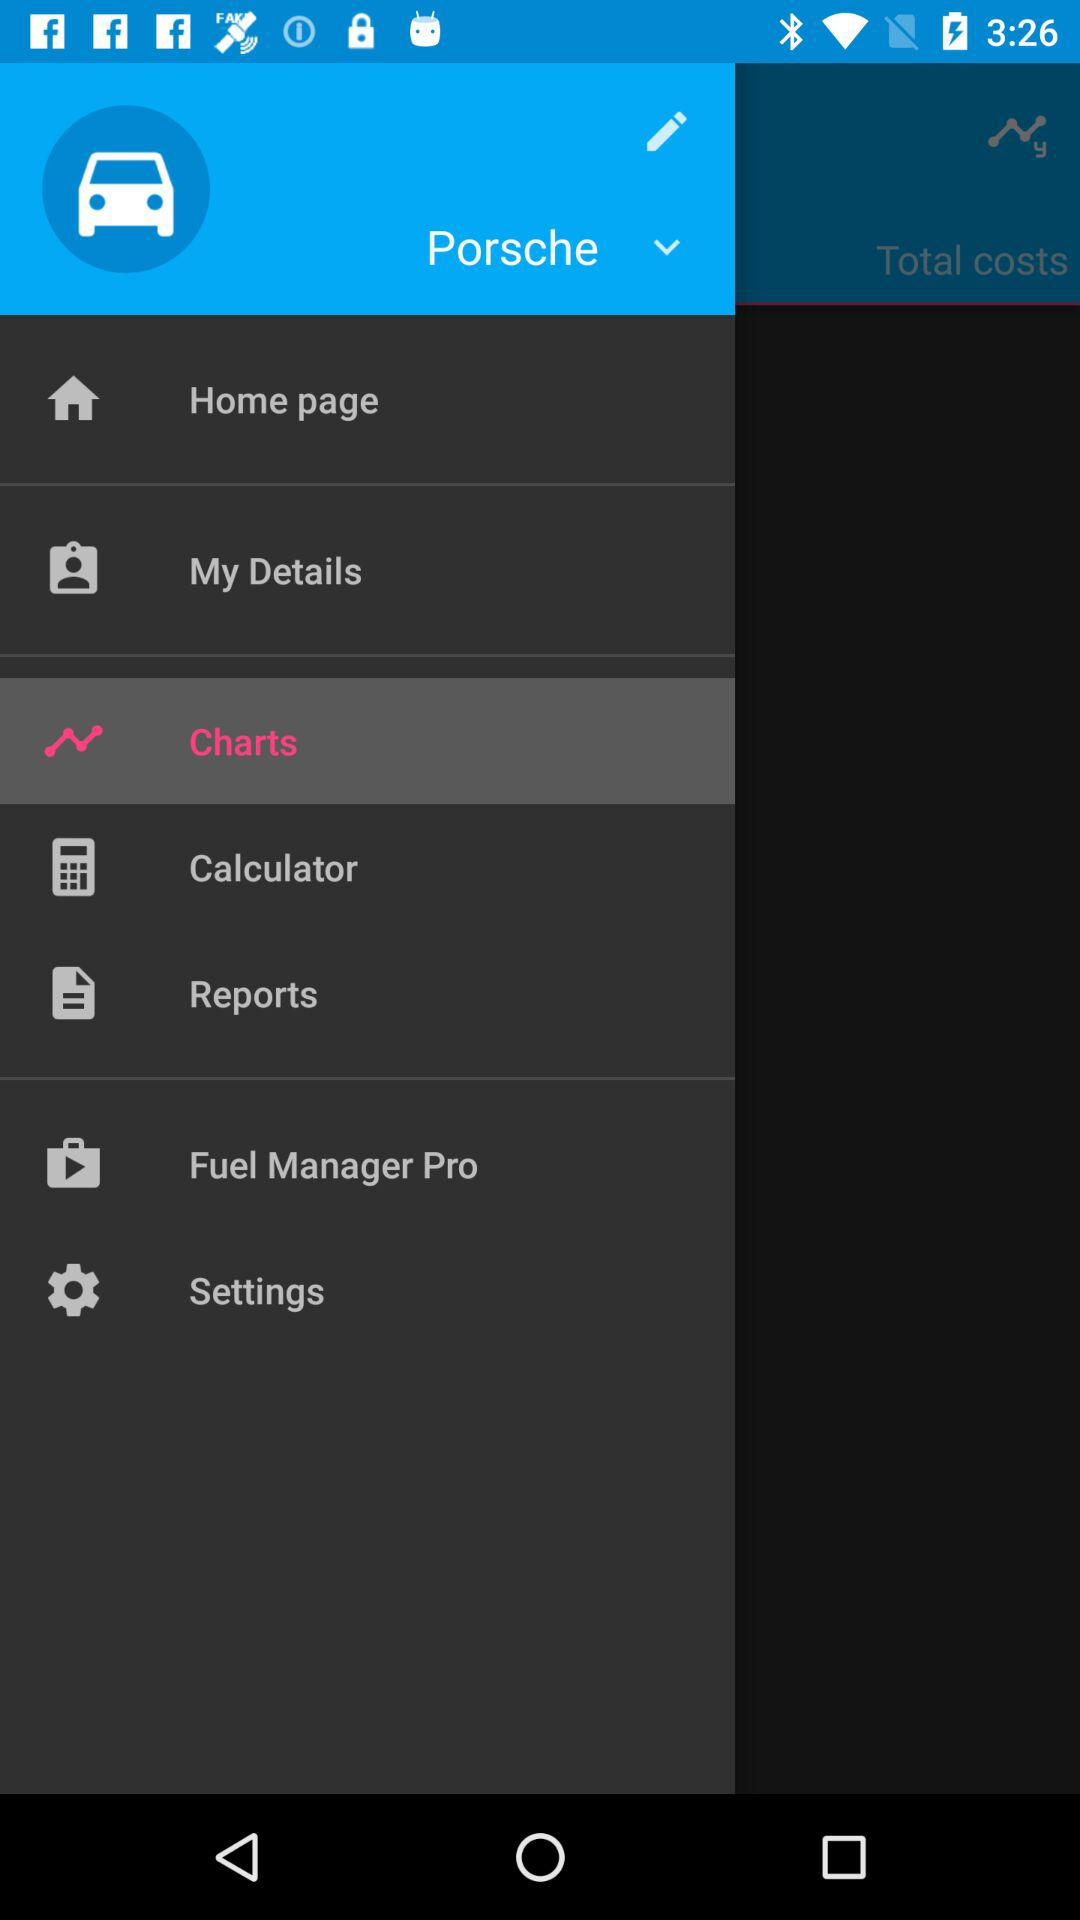What option has been selected? The selected option is "Charts". 